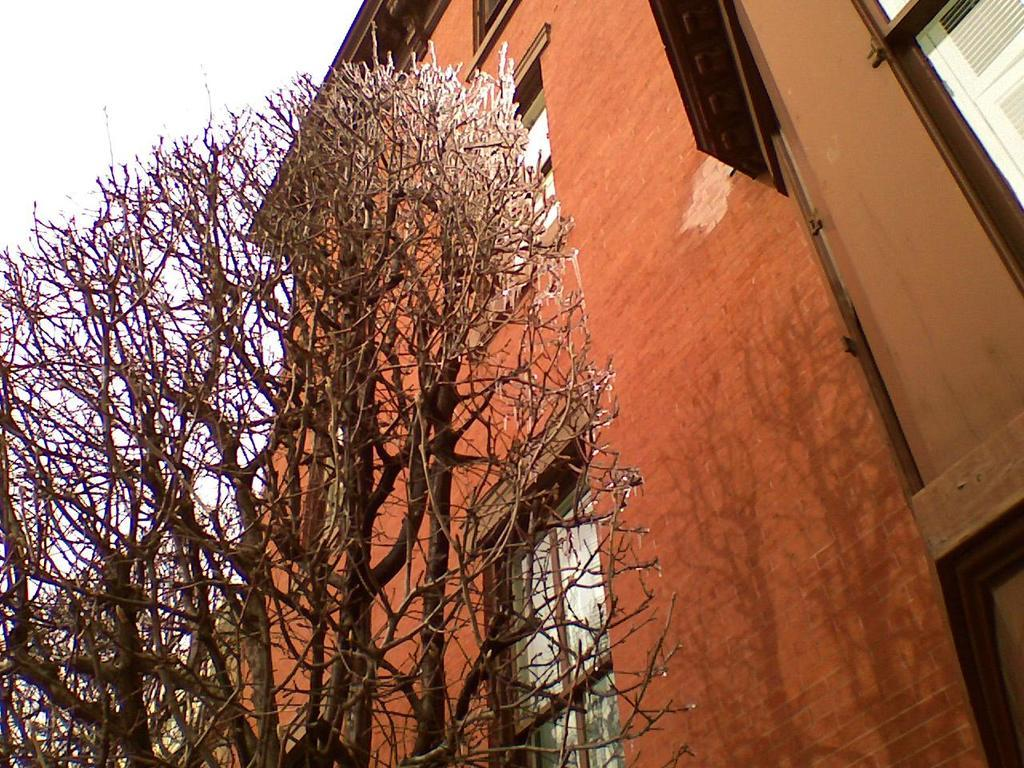What type of view is shown in the image? The image is an outside view. What structure is located on the right side of the image? There is a building with windows on the right side of the image. What type of vegetation is on the left side of the image? There is a tree on the left side of the image. What is visible at the top of the image? The sky is visible at the top of the image. What is the purpose of the lake in the image? There is no lake present in the image; it features a building, a tree, and the sky. What type of pot is used for watering the tree in the image? There is no pot visible in the image; it only shows a tree and a building. 